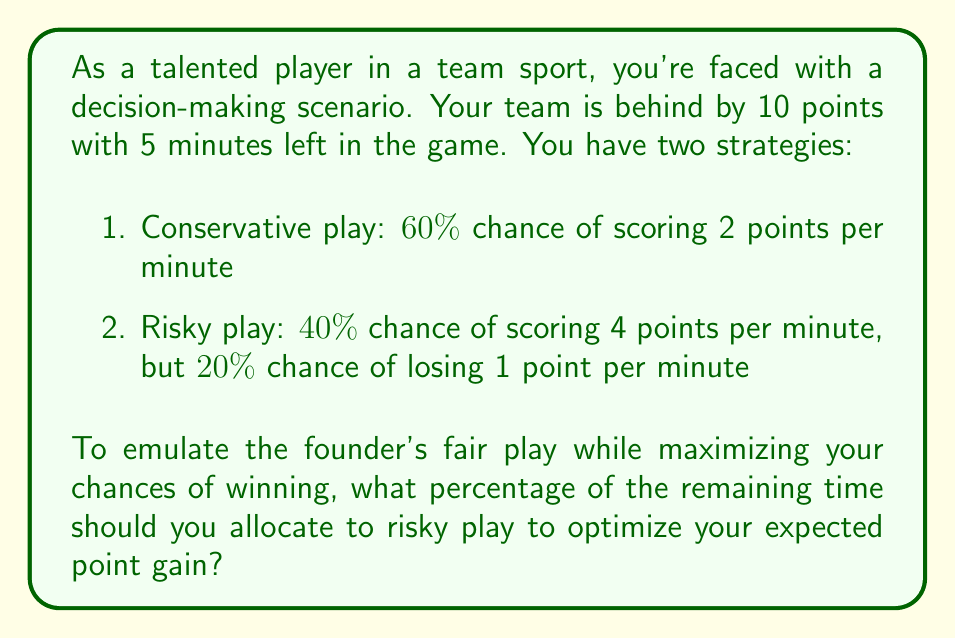What is the answer to this math problem? Let's approach this step-by-step:

1) First, let's calculate the expected points per minute for each strategy:

   Conservative: $0.60 \times 2 = 1.2$ points/minute
   Risky: $(0.40 \times 4) + (0.20 \times (-1)) = 1.4$ points/minute

2) Let $x$ be the fraction of time spent on risky play. Then $(1-x)$ is the fraction spent on conservative play.

3) The expected points gained over 5 minutes can be expressed as:

   $E(points) = 5[(1.4x + 1.2(1-x)]$

4) Simplify the equation:

   $E(points) = 5[1.4x + 1.2 - 1.2x]$
   $E(points) = 5[0.2x + 1.2]$
   $E(points) = x + 6$

5) To win, we need to gain more than 10 points. So we set up the inequality:

   $x + 6 > 10$
   $x > 4$

6) However, $x$ represents a fraction of time and can't exceed 1. The maximum possible value for $x$ is 1, which gives us an expected point gain of 7 points over 5 minutes.

7) Since we can't guarantee a win, the optimal strategy is to maximize the expected point gain, which occurs when $x = 1$.

8) Converting to a percentage: $1 \times 100\% = 100\%$

This result suggests that the optimal strategy is to play risky for the entire remaining time. However, as a player who emulates the founder's fair play, you might consider a more balanced approach, perhaps splitting the time equally between risky and conservative play (50% each) to demonstrate both courage and prudence.
Answer: The mathematically optimal solution is to allocate 100% of the remaining time to risky play. However, considering the persona's desire to emulate the founder's fair play, a more balanced approach of 50% risky play and 50% conservative play might be more appropriate. 